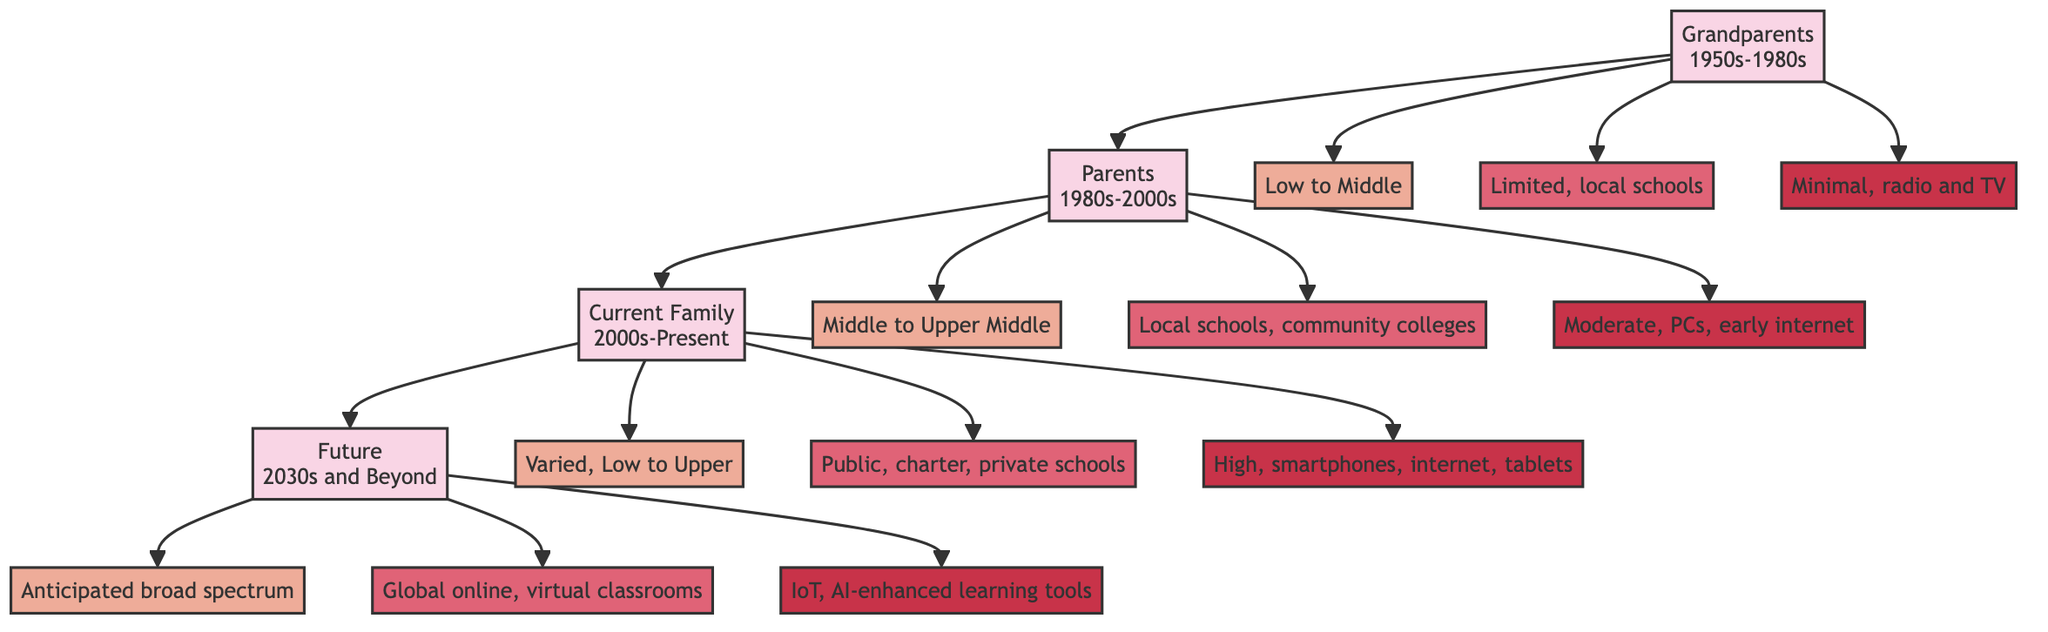What was the socio-economic status of the grandparents' generation? The grandparents' generation is labeled "Low to Middle" for their socio-economic status in the diagram.
Answer: Low to Middle What era does the parent's generation represent? The parent's generation is noted for the era "1980s-2000s" in the diagram.
Answer: 1980s-2000s How many generations are represented in this family tree? The diagram represents four generations: Grandparents, Parents, Current Family, and Future.
Answer: 4 What is the technology access level for the current family? In the diagram, the current family's technology access is classified as "High, smartphones, high-speed internet, tablets."
Answer: High, smartphones, high-speed internet, tablets What type of educational access is anticipated for the future generation? The diagram states the future generation will have "Global online education, virtual classrooms" as their educational access.
Answer: Global online education, virtual classrooms How does the socio-economic status change from grandparents to parents? The socio-economic status of the grandparents ("Low to Middle") progresses to the parents' generation, which is classified as "Middle to Upper Middle." Therefore, it shows an upward trend in socio-economic status.
Answer: Upward trend What was the primary technology available to grandparents? The grandparents had "Minimal, radio and TV" as their primary technology access during their generation, as stated in the diagram.
Answer: Minimal, radio and TV What is the expected socio-economic status for the future generation? The future generational socio-economic status is marked as "Anticipated broad spectrum" in the diagram.
Answer: Anticipated broad spectrum Which generation had access to community colleges for education? The parents' generation is described as having "Local schools, community colleges" for education access in the diagram.
Answer: Parents 